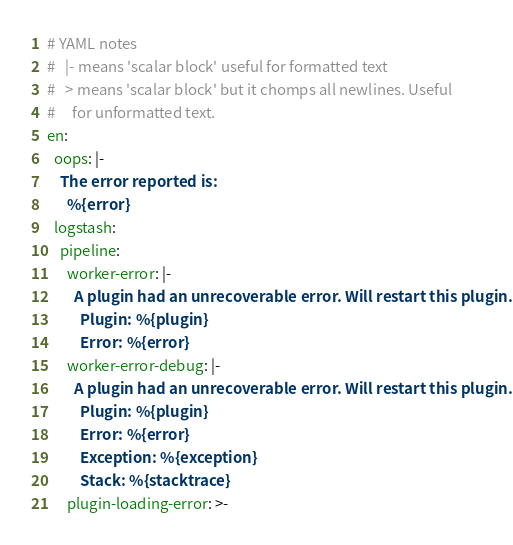Convert code to text. <code><loc_0><loc_0><loc_500><loc_500><_YAML_># YAML notes
#   |- means 'scalar block' useful for formatted text
#   > means 'scalar block' but it chomps all newlines. Useful 
#     for unformatted text.
en:
  oops: |-
    The error reported is: 
      %{error}
  logstash:
    pipeline:
      worker-error: |-
        A plugin had an unrecoverable error. Will restart this plugin.
          Plugin: %{plugin}
          Error: %{error}
      worker-error-debug: |-
        A plugin had an unrecoverable error. Will restart this plugin.
          Plugin: %{plugin}
          Error: %{error}
          Exception: %{exception}
          Stack: %{stacktrace}
      plugin-loading-error: >-</code> 